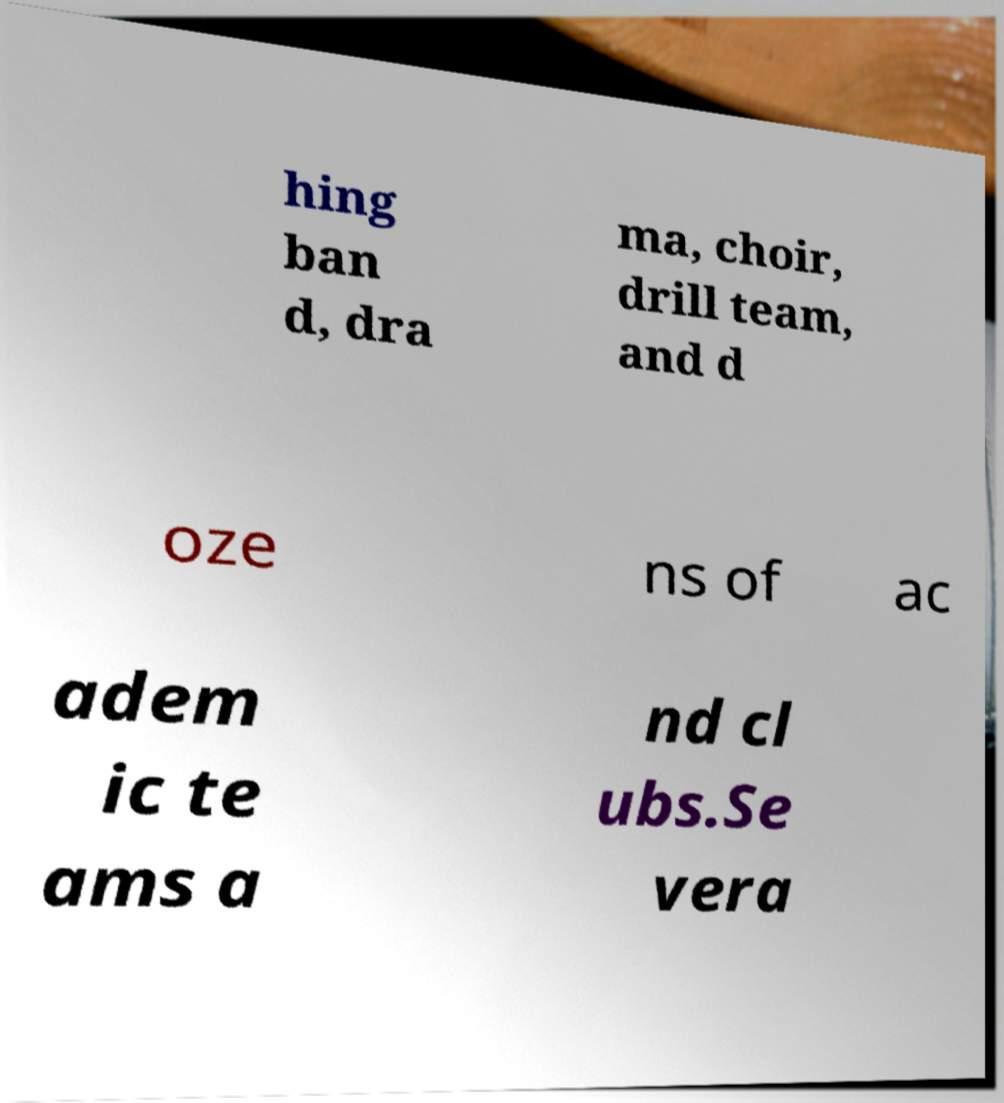Please read and relay the text visible in this image. What does it say? hing ban d, dra ma, choir, drill team, and d oze ns of ac adem ic te ams a nd cl ubs.Se vera 